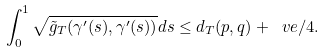<formula> <loc_0><loc_0><loc_500><loc_500>\int _ { 0 } ^ { 1 } \sqrt { \tilde { g } _ { T } ( \gamma ^ { \prime } ( s ) , \gamma ^ { \prime } ( s ) ) } d s \leq d _ { T } ( p , q ) + \ v e / 4 .</formula> 